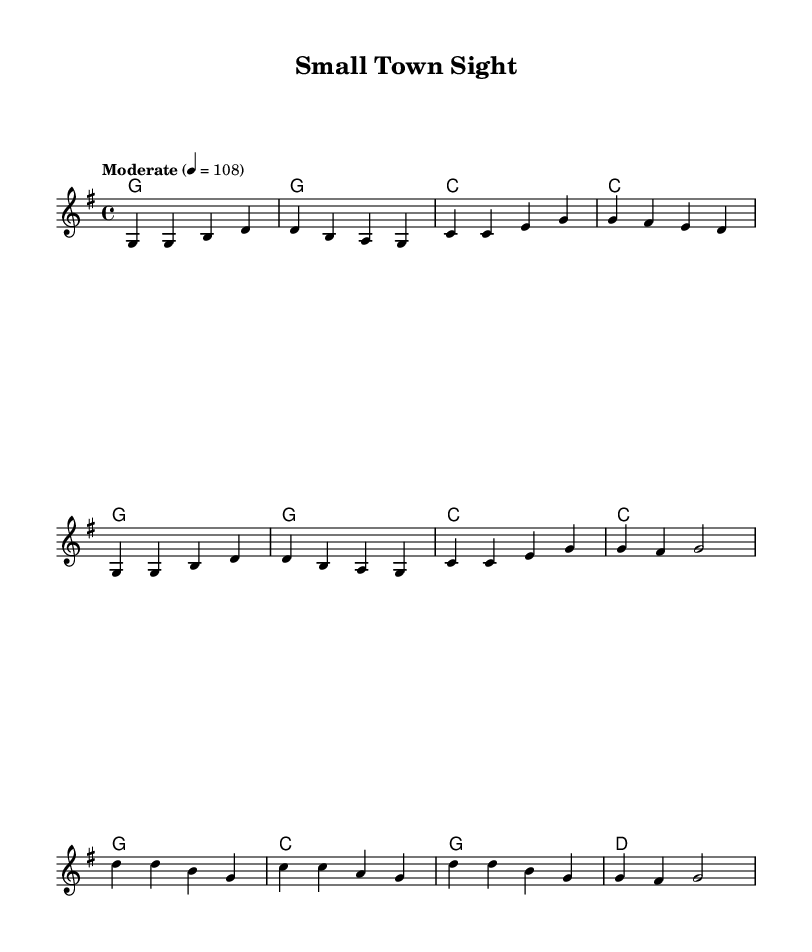What is the key signature of this music? The key signature is indicated at the beginning of the staff where it shows one sharp. This denotes that the piece is in G major.
Answer: G major What is the time signature of this music? The time signature appears at the beginning of the score after the key signature. It is expressed as 4/4, which means there are four beats per measure and the quarter note gets one beat.
Answer: 4/4 What is the tempo of the piece? The tempo marking is found after the time signature, specified as "Moderate" with a metronome marking of 108. This indicates the speed at which to play the piece.
Answer: 108 How many measures are in the verse? The verse contains two musical phrases, each consisting of four measures (8 measures total). Each group of notes is separated by vertical lines that indicate measure boundaries.
Answer: 8 measures What are the main themes found in the lyrics of the chorus? The chorus emphasizes the focus on providing vision care in a small-town setting, reflecting a sense of community and personal touch. Analyzing the lyrics, this theme revolves around clarity of vision and care for individuals.
Answer: Vision care, community How does the chord progression support the country rock style? The chord progression primarily features simple triads like G, C, and D, which are typical in country rock music. These chords contribute to the straightforward and accessible sound that is characteristic of the genre. The use of these stable, consonant chords complements the melody and reinforces the nostalgic feel.
Answer: G, C, D chords 